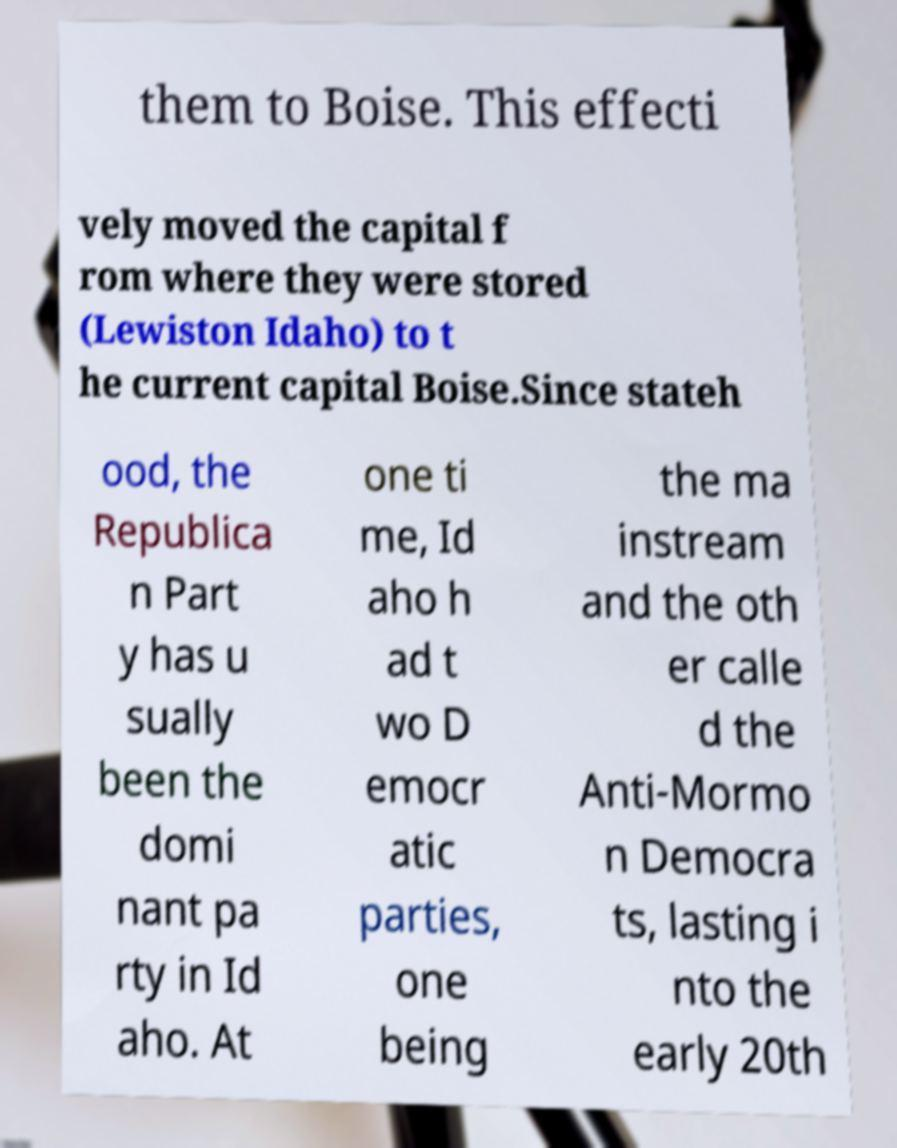There's text embedded in this image that I need extracted. Can you transcribe it verbatim? them to Boise. This effecti vely moved the capital f rom where they were stored (Lewiston Idaho) to t he current capital Boise.Since stateh ood, the Republica n Part y has u sually been the domi nant pa rty in Id aho. At one ti me, Id aho h ad t wo D emocr atic parties, one being the ma instream and the oth er calle d the Anti-Mormo n Democra ts, lasting i nto the early 20th 